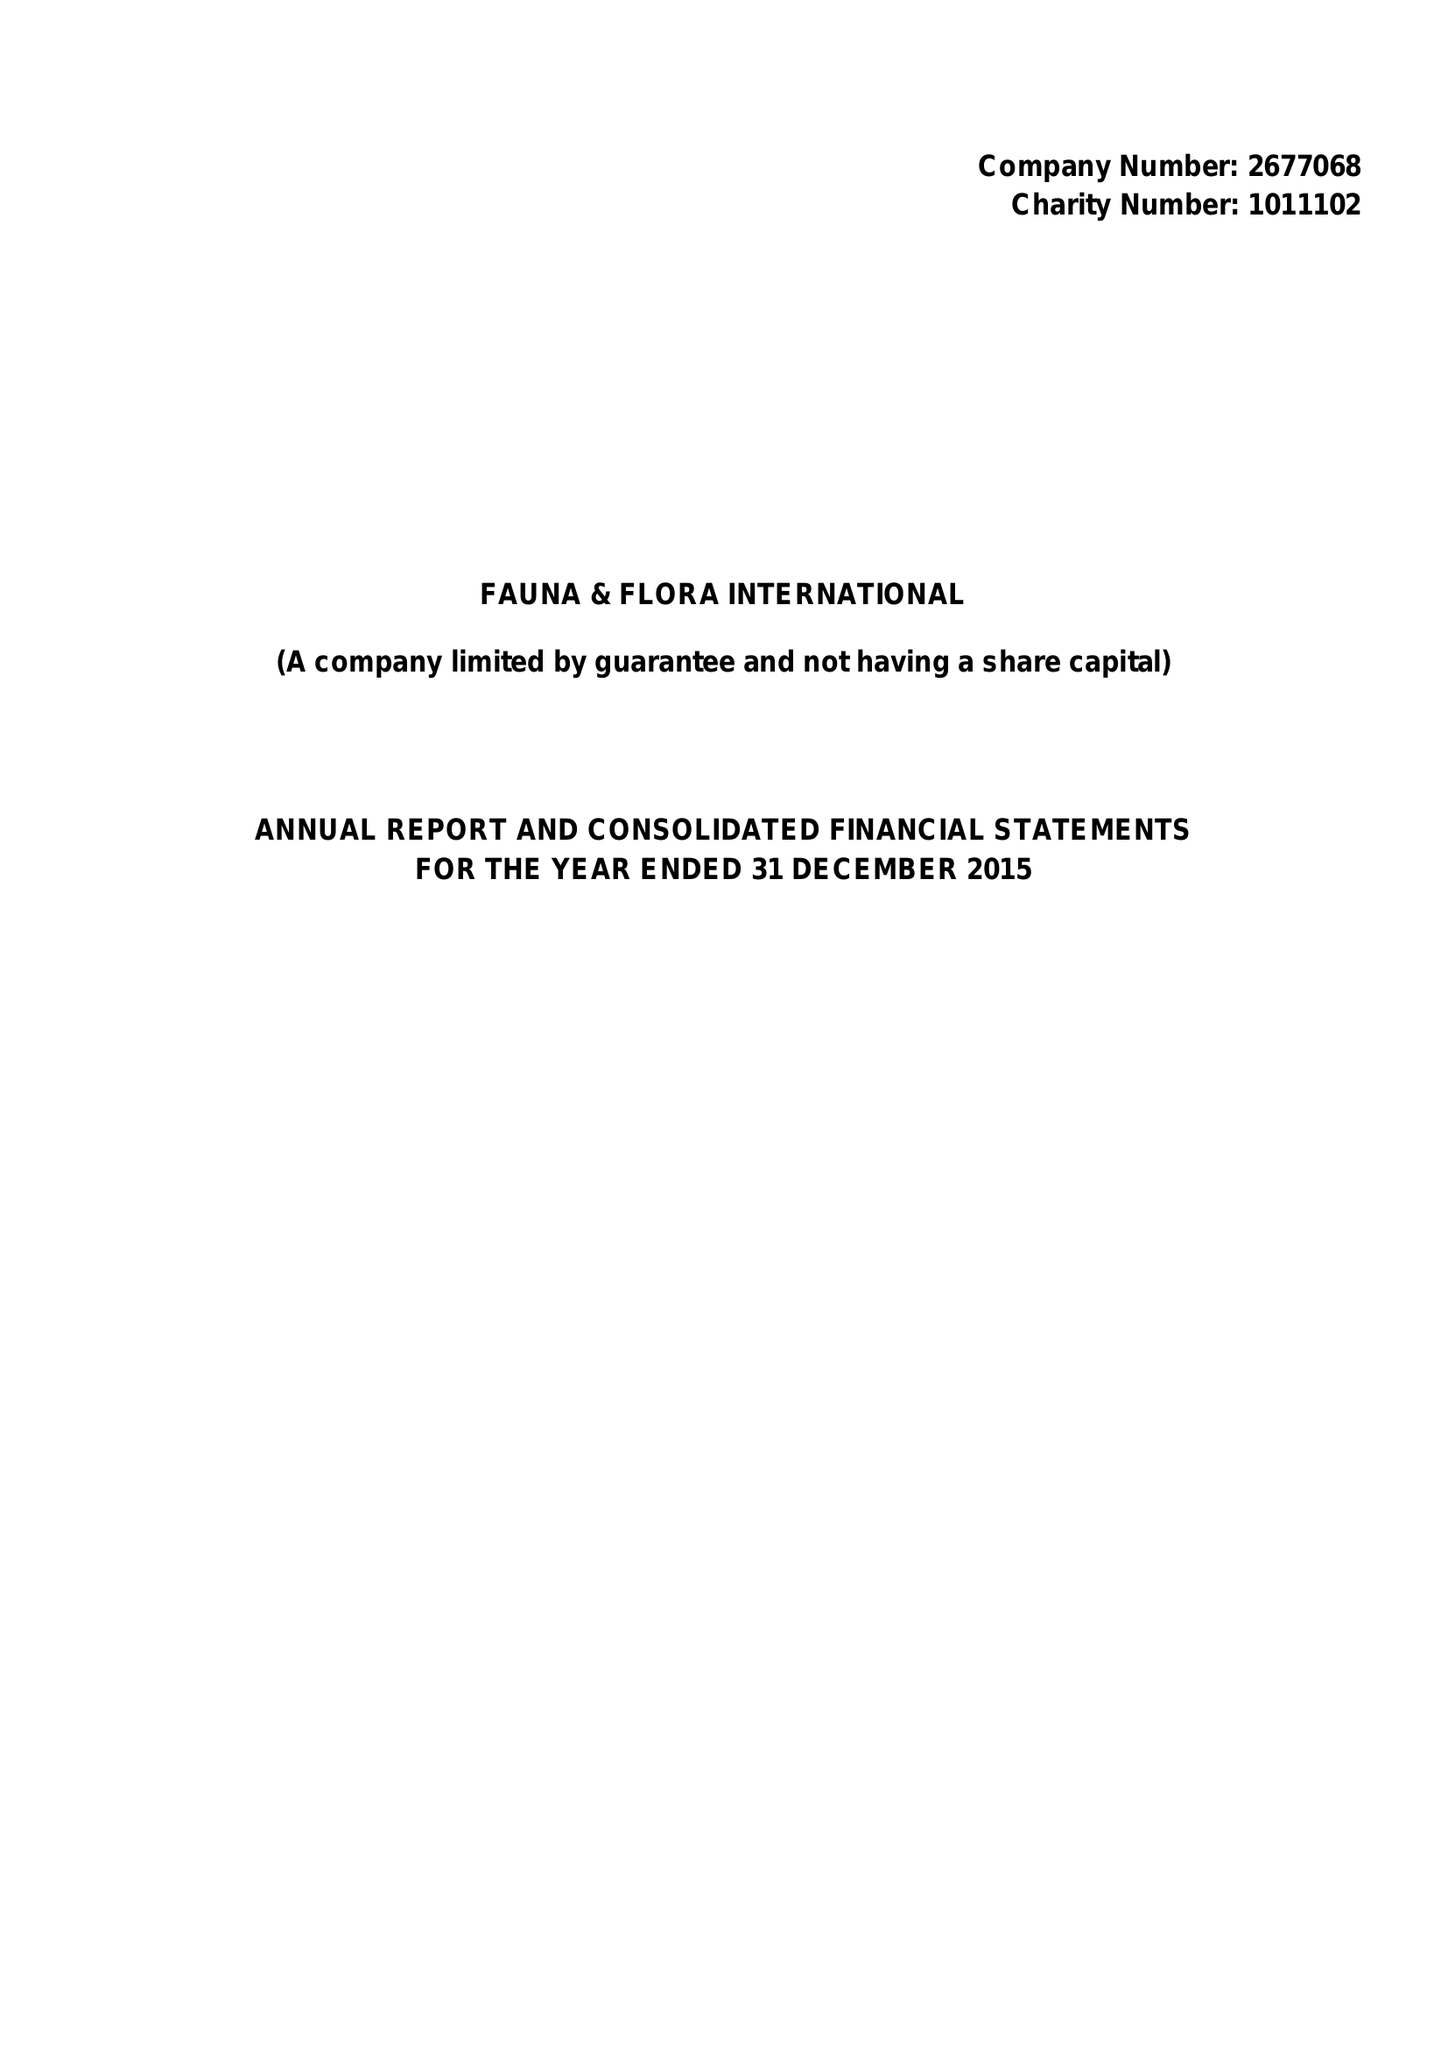What is the value for the address__post_town?
Answer the question using a single word or phrase. CAMBRIDGE 